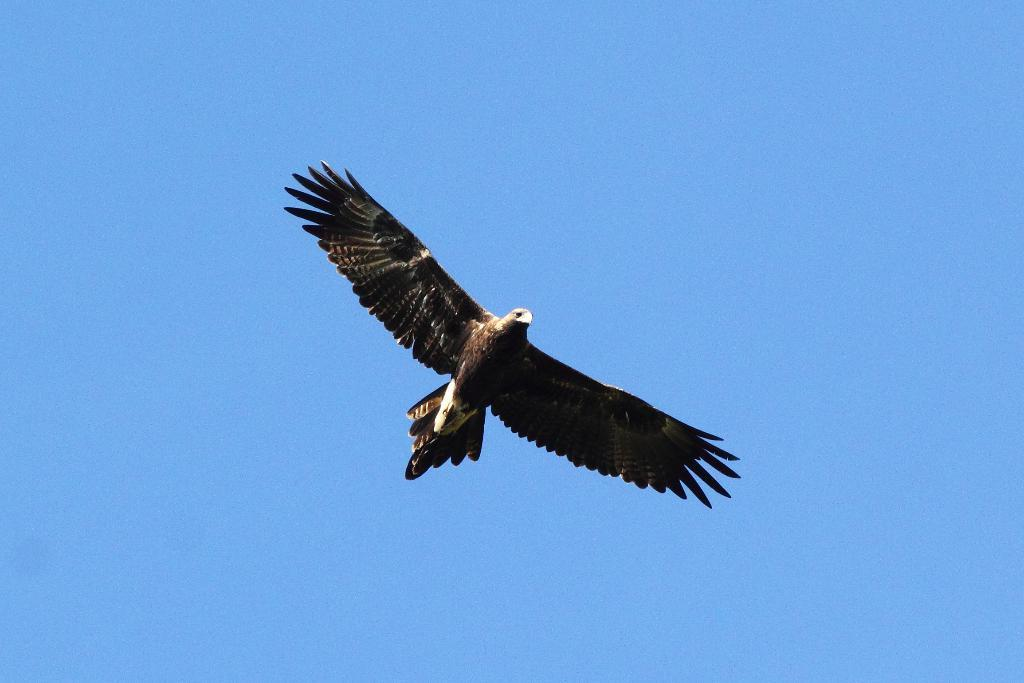What animal is the main subject of the picture? There is an eagle in the picture. What is the eagle doing in the image? The eagle is flying. What color is the sky in the image? The sky is blue in the image. What colors can be seen on the eagle? The eagle is brown and white in color. How many girls are holding a cake in the image? There are no girls or cake present in the image; it features an eagle flying in the blue sky. What type of ant can be seen crawling on the eagle's wing in the image? There are no ants present in the image; it features an eagle flying in the blue sky. 